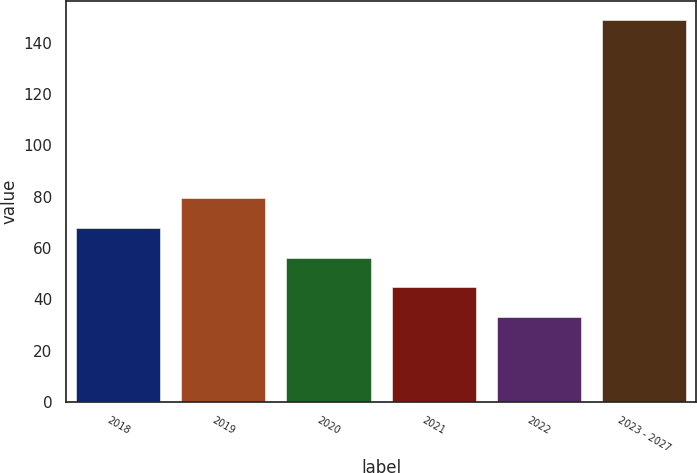Convert chart to OTSL. <chart><loc_0><loc_0><loc_500><loc_500><bar_chart><fcel>2018<fcel>2019<fcel>2020<fcel>2021<fcel>2022<fcel>2023 - 2027<nl><fcel>67.8<fcel>79.4<fcel>56.2<fcel>44.6<fcel>33<fcel>149<nl></chart> 